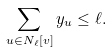Convert formula to latex. <formula><loc_0><loc_0><loc_500><loc_500>\sum _ { u \in N _ { \ell } [ v ] } y _ { u } \leq \ell .</formula> 